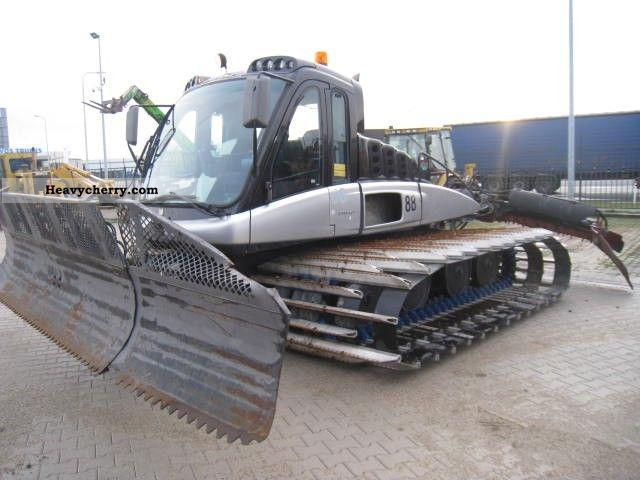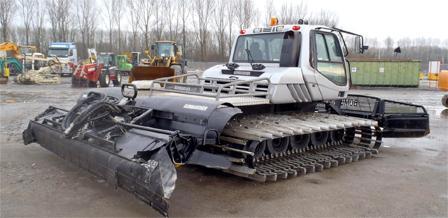The first image is the image on the left, the second image is the image on the right. Given the left and right images, does the statement "At least one image shows a vehicle with tank-like tracks instead of wheels." hold true? Answer yes or no. Yes. 